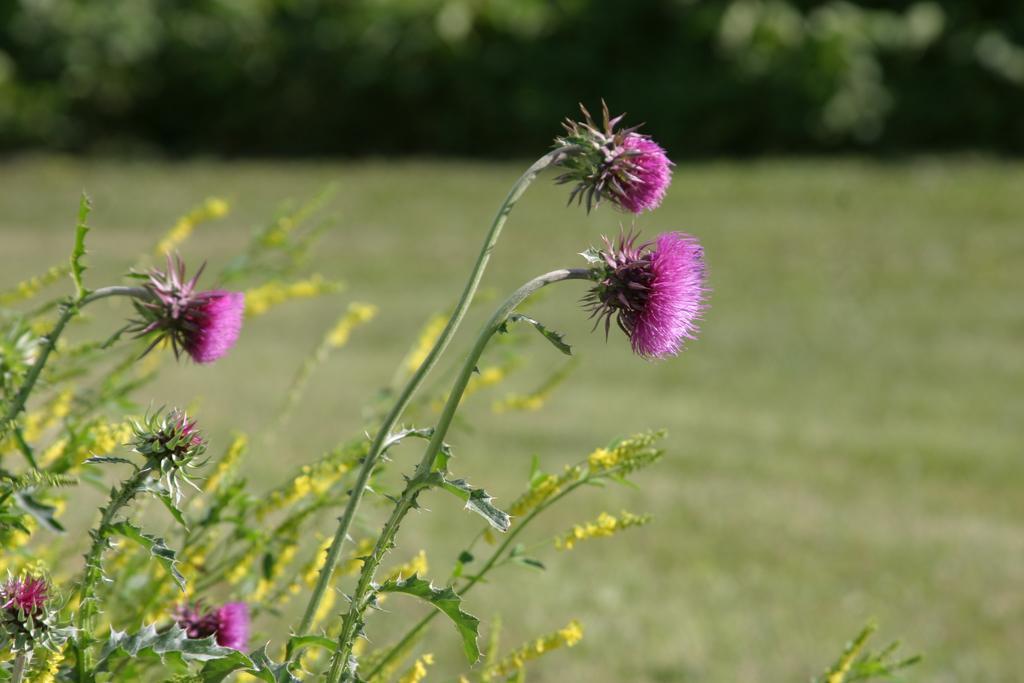Describe this image in one or two sentences. In the picture I can see the purple color flowers of the plant. The background of the image is blurred, where we can see grass and trees. 